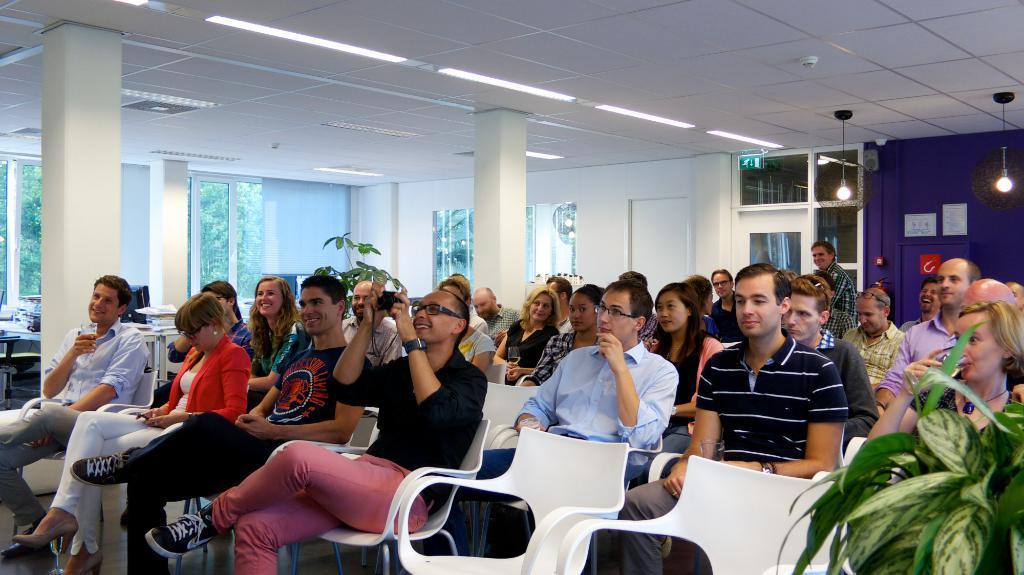Describe this image in one or two sentences. In the picture we can see the hall with men and women are sitting on the chairs and near them, we can see a plant and in the background, we can see two pillars and behind it we can see the wall with windows and glasses to it. 